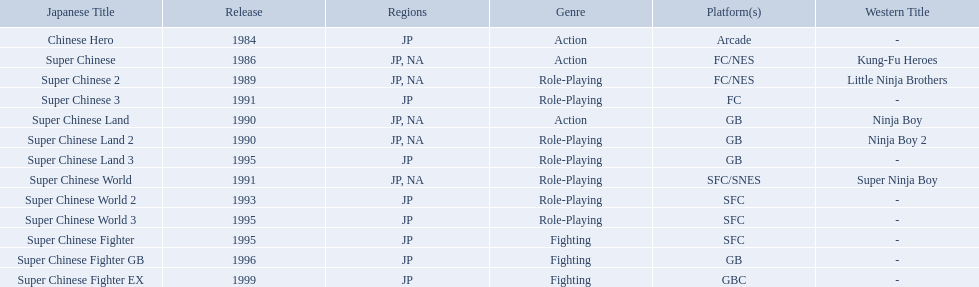Super ninja world was released in what countries? JP, NA. What was the original name for this title? Super Chinese World. 